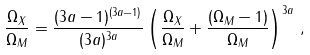Convert formula to latex. <formula><loc_0><loc_0><loc_500><loc_500>\frac { \Omega _ { X } } { \Omega _ { M } } = \frac { ( 3 a - 1 ) ^ { ( 3 a - 1 ) } } { ( 3 a ) ^ { 3 a } } \left ( \frac { \Omega _ { X } } { \Omega _ { M } } + \frac { ( \Omega _ { M } - 1 ) } { \Omega _ { M } } \right ) ^ { 3 a } \, ,</formula> 